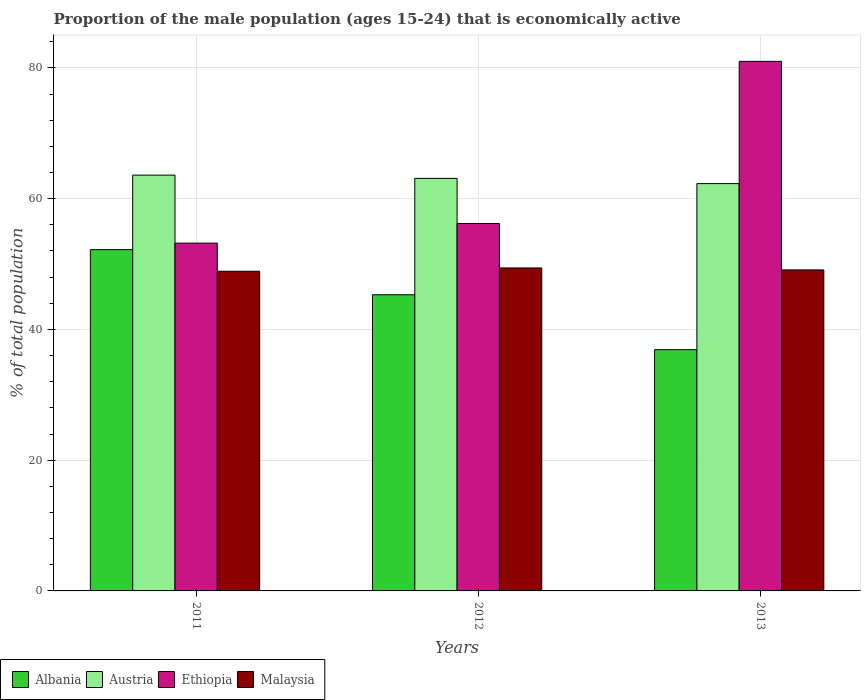How many different coloured bars are there?
Give a very brief answer. 4. How many bars are there on the 3rd tick from the left?
Provide a succinct answer. 4. What is the proportion of the male population that is economically active in Ethiopia in 2011?
Keep it short and to the point. 53.2. Across all years, what is the maximum proportion of the male population that is economically active in Albania?
Offer a very short reply. 52.2. Across all years, what is the minimum proportion of the male population that is economically active in Malaysia?
Ensure brevity in your answer.  48.9. What is the total proportion of the male population that is economically active in Malaysia in the graph?
Give a very brief answer. 147.4. What is the difference between the proportion of the male population that is economically active in Ethiopia in 2012 and that in 2013?
Offer a terse response. -24.8. What is the difference between the proportion of the male population that is economically active in Austria in 2011 and the proportion of the male population that is economically active in Albania in 2013?
Make the answer very short. 26.7. What is the average proportion of the male population that is economically active in Malaysia per year?
Provide a short and direct response. 49.13. In the year 2012, what is the difference between the proportion of the male population that is economically active in Ethiopia and proportion of the male population that is economically active in Albania?
Keep it short and to the point. 10.9. In how many years, is the proportion of the male population that is economically active in Austria greater than 76 %?
Provide a short and direct response. 0. What is the ratio of the proportion of the male population that is economically active in Ethiopia in 2011 to that in 2013?
Provide a succinct answer. 0.66. Is the proportion of the male population that is economically active in Ethiopia in 2012 less than that in 2013?
Provide a succinct answer. Yes. Is the difference between the proportion of the male population that is economically active in Ethiopia in 2011 and 2013 greater than the difference between the proportion of the male population that is economically active in Albania in 2011 and 2013?
Offer a very short reply. No. What is the difference between the highest and the second highest proportion of the male population that is economically active in Albania?
Ensure brevity in your answer.  6.9. What is the difference between the highest and the lowest proportion of the male population that is economically active in Austria?
Offer a very short reply. 1.3. Is the sum of the proportion of the male population that is economically active in Malaysia in 2012 and 2013 greater than the maximum proportion of the male population that is economically active in Ethiopia across all years?
Offer a terse response. Yes. What does the 3rd bar from the left in 2011 represents?
Provide a short and direct response. Ethiopia. What does the 2nd bar from the right in 2011 represents?
Provide a succinct answer. Ethiopia. How many bars are there?
Your response must be concise. 12. How many years are there in the graph?
Ensure brevity in your answer.  3. Are the values on the major ticks of Y-axis written in scientific E-notation?
Keep it short and to the point. No. Does the graph contain any zero values?
Make the answer very short. No. Does the graph contain grids?
Keep it short and to the point. Yes. How are the legend labels stacked?
Make the answer very short. Horizontal. What is the title of the graph?
Provide a short and direct response. Proportion of the male population (ages 15-24) that is economically active. What is the label or title of the X-axis?
Provide a short and direct response. Years. What is the label or title of the Y-axis?
Ensure brevity in your answer.  % of total population. What is the % of total population of Albania in 2011?
Give a very brief answer. 52.2. What is the % of total population in Austria in 2011?
Provide a short and direct response. 63.6. What is the % of total population in Ethiopia in 2011?
Your response must be concise. 53.2. What is the % of total population of Malaysia in 2011?
Offer a very short reply. 48.9. What is the % of total population of Albania in 2012?
Keep it short and to the point. 45.3. What is the % of total population of Austria in 2012?
Keep it short and to the point. 63.1. What is the % of total population in Ethiopia in 2012?
Your answer should be compact. 56.2. What is the % of total population in Malaysia in 2012?
Keep it short and to the point. 49.4. What is the % of total population in Albania in 2013?
Make the answer very short. 36.9. What is the % of total population of Austria in 2013?
Offer a very short reply. 62.3. What is the % of total population of Malaysia in 2013?
Your response must be concise. 49.1. Across all years, what is the maximum % of total population of Albania?
Keep it short and to the point. 52.2. Across all years, what is the maximum % of total population of Austria?
Offer a terse response. 63.6. Across all years, what is the maximum % of total population of Ethiopia?
Provide a succinct answer. 81. Across all years, what is the maximum % of total population of Malaysia?
Offer a very short reply. 49.4. Across all years, what is the minimum % of total population in Albania?
Give a very brief answer. 36.9. Across all years, what is the minimum % of total population in Austria?
Your answer should be very brief. 62.3. Across all years, what is the minimum % of total population of Ethiopia?
Ensure brevity in your answer.  53.2. Across all years, what is the minimum % of total population in Malaysia?
Offer a very short reply. 48.9. What is the total % of total population of Albania in the graph?
Your answer should be very brief. 134.4. What is the total % of total population of Austria in the graph?
Make the answer very short. 189. What is the total % of total population of Ethiopia in the graph?
Ensure brevity in your answer.  190.4. What is the total % of total population in Malaysia in the graph?
Offer a very short reply. 147.4. What is the difference between the % of total population in Austria in 2011 and that in 2012?
Ensure brevity in your answer.  0.5. What is the difference between the % of total population in Albania in 2011 and that in 2013?
Your response must be concise. 15.3. What is the difference between the % of total population of Austria in 2011 and that in 2013?
Offer a terse response. 1.3. What is the difference between the % of total population in Ethiopia in 2011 and that in 2013?
Your answer should be compact. -27.8. What is the difference between the % of total population of Albania in 2012 and that in 2013?
Provide a short and direct response. 8.4. What is the difference between the % of total population in Austria in 2012 and that in 2013?
Your response must be concise. 0.8. What is the difference between the % of total population in Ethiopia in 2012 and that in 2013?
Provide a succinct answer. -24.8. What is the difference between the % of total population of Malaysia in 2012 and that in 2013?
Your response must be concise. 0.3. What is the difference between the % of total population of Albania in 2011 and the % of total population of Austria in 2012?
Keep it short and to the point. -10.9. What is the difference between the % of total population in Albania in 2011 and the % of total population in Ethiopia in 2013?
Your answer should be very brief. -28.8. What is the difference between the % of total population in Austria in 2011 and the % of total population in Ethiopia in 2013?
Your answer should be compact. -17.4. What is the difference between the % of total population in Ethiopia in 2011 and the % of total population in Malaysia in 2013?
Make the answer very short. 4.1. What is the difference between the % of total population in Albania in 2012 and the % of total population in Austria in 2013?
Keep it short and to the point. -17. What is the difference between the % of total population in Albania in 2012 and the % of total population in Ethiopia in 2013?
Keep it short and to the point. -35.7. What is the difference between the % of total population of Austria in 2012 and the % of total population of Ethiopia in 2013?
Give a very brief answer. -17.9. What is the average % of total population in Albania per year?
Keep it short and to the point. 44.8. What is the average % of total population in Austria per year?
Your answer should be compact. 63. What is the average % of total population in Ethiopia per year?
Provide a short and direct response. 63.47. What is the average % of total population of Malaysia per year?
Your answer should be compact. 49.13. In the year 2011, what is the difference between the % of total population in Albania and % of total population in Austria?
Keep it short and to the point. -11.4. In the year 2011, what is the difference between the % of total population in Albania and % of total population in Malaysia?
Offer a very short reply. 3.3. In the year 2011, what is the difference between the % of total population in Austria and % of total population in Ethiopia?
Your answer should be very brief. 10.4. In the year 2011, what is the difference between the % of total population of Austria and % of total population of Malaysia?
Offer a very short reply. 14.7. In the year 2011, what is the difference between the % of total population of Ethiopia and % of total population of Malaysia?
Provide a succinct answer. 4.3. In the year 2012, what is the difference between the % of total population in Albania and % of total population in Austria?
Provide a short and direct response. -17.8. In the year 2012, what is the difference between the % of total population in Albania and % of total population in Ethiopia?
Give a very brief answer. -10.9. In the year 2012, what is the difference between the % of total population in Austria and % of total population in Ethiopia?
Your answer should be very brief. 6.9. In the year 2012, what is the difference between the % of total population in Ethiopia and % of total population in Malaysia?
Offer a very short reply. 6.8. In the year 2013, what is the difference between the % of total population in Albania and % of total population in Austria?
Offer a very short reply. -25.4. In the year 2013, what is the difference between the % of total population of Albania and % of total population of Ethiopia?
Offer a very short reply. -44.1. In the year 2013, what is the difference between the % of total population of Austria and % of total population of Ethiopia?
Keep it short and to the point. -18.7. In the year 2013, what is the difference between the % of total population of Austria and % of total population of Malaysia?
Provide a succinct answer. 13.2. In the year 2013, what is the difference between the % of total population of Ethiopia and % of total population of Malaysia?
Offer a terse response. 31.9. What is the ratio of the % of total population in Albania in 2011 to that in 2012?
Offer a very short reply. 1.15. What is the ratio of the % of total population of Austria in 2011 to that in 2012?
Give a very brief answer. 1.01. What is the ratio of the % of total population of Ethiopia in 2011 to that in 2012?
Give a very brief answer. 0.95. What is the ratio of the % of total population of Malaysia in 2011 to that in 2012?
Your answer should be very brief. 0.99. What is the ratio of the % of total population in Albania in 2011 to that in 2013?
Offer a terse response. 1.41. What is the ratio of the % of total population of Austria in 2011 to that in 2013?
Give a very brief answer. 1.02. What is the ratio of the % of total population in Ethiopia in 2011 to that in 2013?
Provide a short and direct response. 0.66. What is the ratio of the % of total population in Albania in 2012 to that in 2013?
Give a very brief answer. 1.23. What is the ratio of the % of total population of Austria in 2012 to that in 2013?
Keep it short and to the point. 1.01. What is the ratio of the % of total population of Ethiopia in 2012 to that in 2013?
Ensure brevity in your answer.  0.69. What is the difference between the highest and the second highest % of total population in Albania?
Ensure brevity in your answer.  6.9. What is the difference between the highest and the second highest % of total population of Austria?
Keep it short and to the point. 0.5. What is the difference between the highest and the second highest % of total population in Ethiopia?
Keep it short and to the point. 24.8. What is the difference between the highest and the lowest % of total population of Albania?
Your response must be concise. 15.3. What is the difference between the highest and the lowest % of total population of Austria?
Offer a very short reply. 1.3. What is the difference between the highest and the lowest % of total population of Ethiopia?
Offer a terse response. 27.8. 